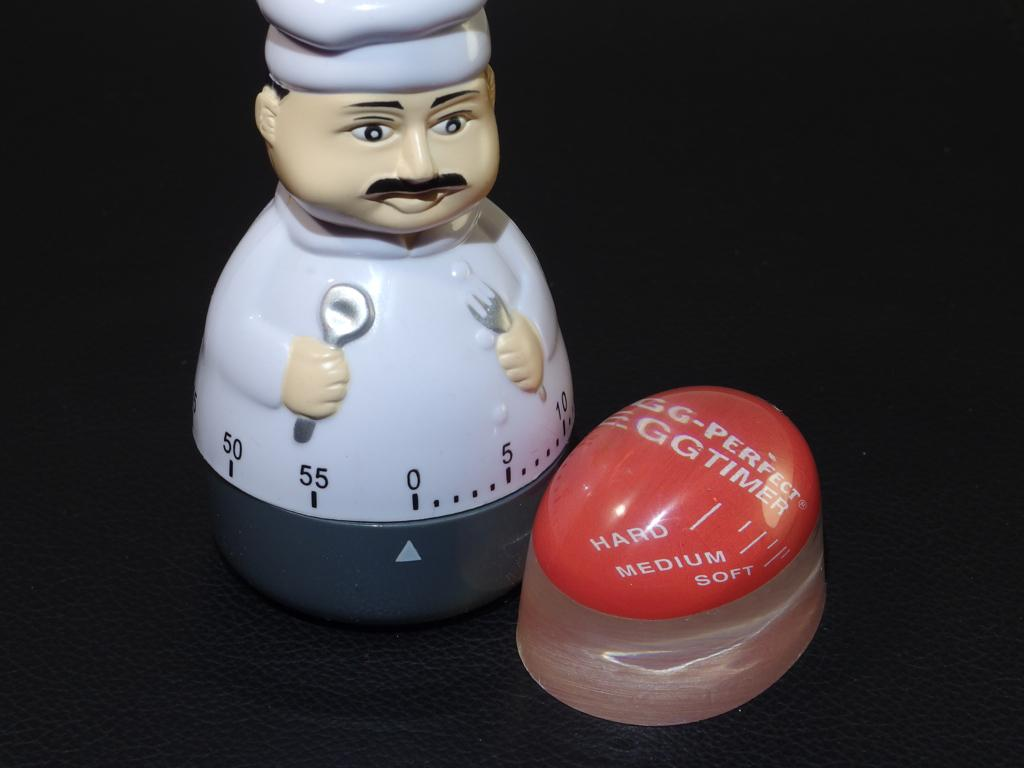What type of toy is in the image? There is a timer toy in the image. What color is the background of the image? The background of the image is black. Can you see any veins in the image? There are no veins present in the image; it features a timer toy against a black background. 